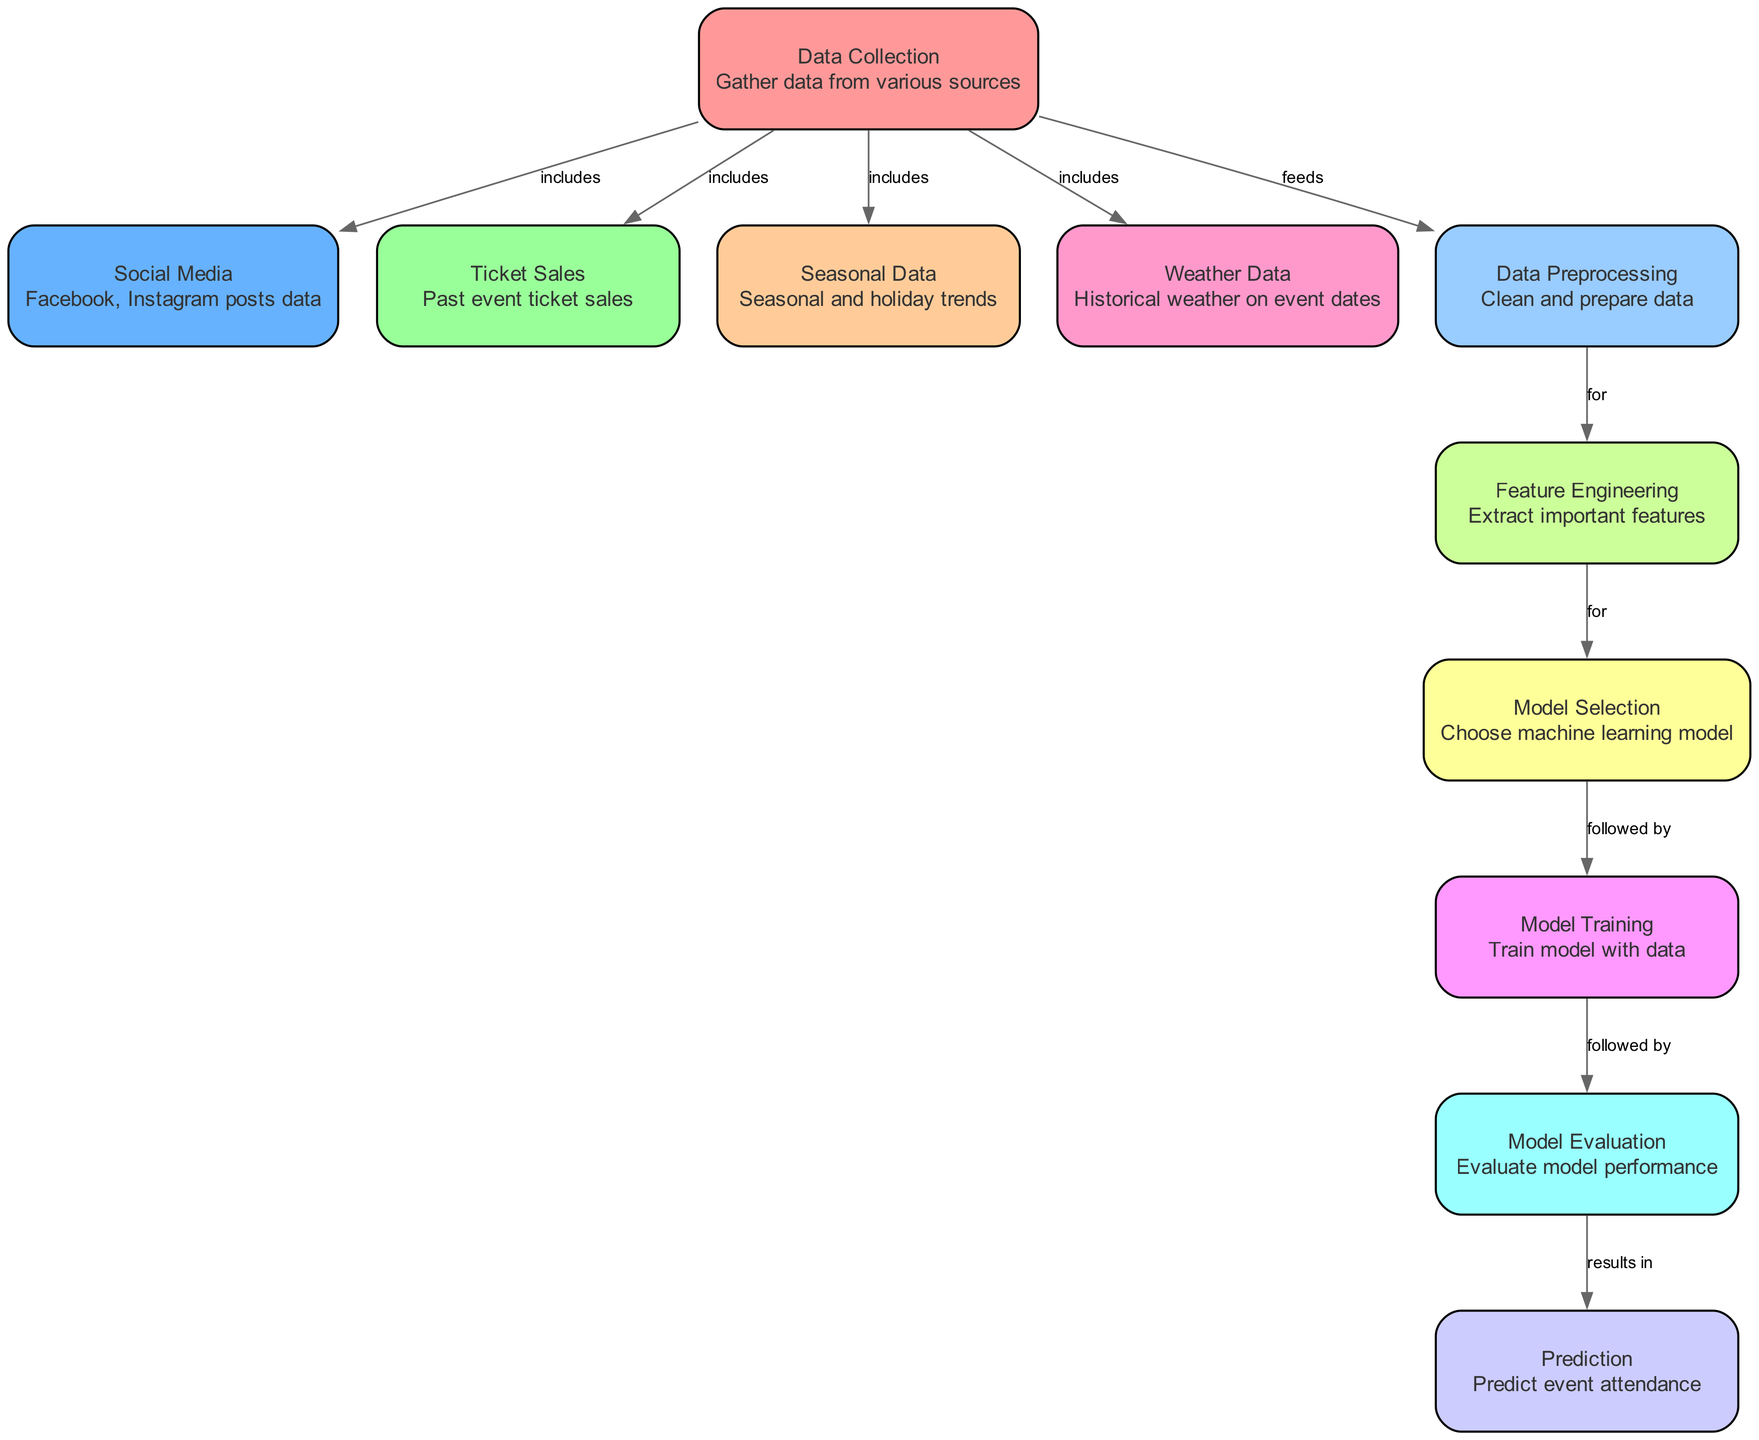What is the first step in the diagram? The first step in the diagram is "Data Collection." This is the starting point where various data sources are gathered before any analysis can take place.
Answer: Data Collection How many nodes are there in the diagram? The diagram contains a total of 11 nodes, as each node represents a distinct part of the process of predicting band attendance.
Answer: 11 What type of data does the "Social Media" node represent? The "Social Media" node represents data gathered from platforms like Facebook and Instagram, focusing on posts that can influence attendance.
Answer: Facebook, Instagram posts data Which nodes are included in the "Data Collection"? "Data Collection" includes the nodes "Social Media," "Ticket Sales," "Seasonal Data," and "Weather Data." These are the data inputs that feed into the preprocessing step.
Answer: Social Media, Ticket Sales, Seasonal Data, Weather Data What directly follows "Data Preprocessing"? The step that directly follows "Data Preprocessing" is "Feature Engineering." This transition indicates that data must be refined into important features before model selection can occur.
Answer: Feature Engineering What is the final output of the diagram? The final output of the diagram is the "Prediction" node, which provides the anticipated event attendance based on all preceding steps in the workflow.
Answer: Prediction How does "Model Evaluation" relate to "Model Training"? "Model Evaluation" is a step that follows "Model Training," meaning that once the model is trained, its performance is evaluated to ensure it meets desired metrics.
Answer: Followed by What is the purpose of "Feature Engineering"? The purpose of "Feature Engineering" is to extract important features from the cleaned dataset that will improve the performance of the machine learning model.
Answer: Extract important features Which node feeds into "Model Selection"? The node that feeds into "Model Selection" is "Feature Engineering." After important features are extracted, a suitable machine learning model can be selected based on those features.
Answer: Feature Engineering 